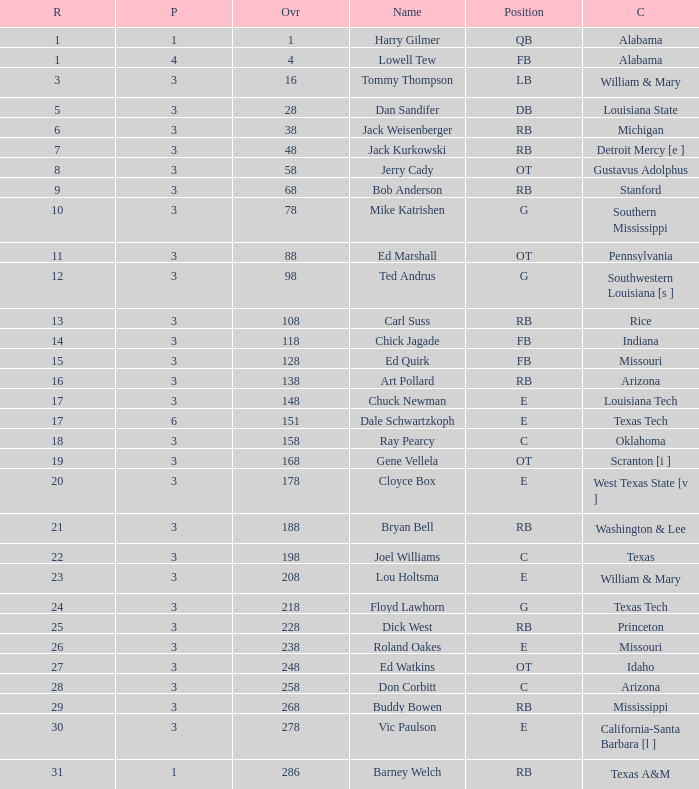Which Overall has a Name of bob anderson, and a Round smaller than 9? None. 